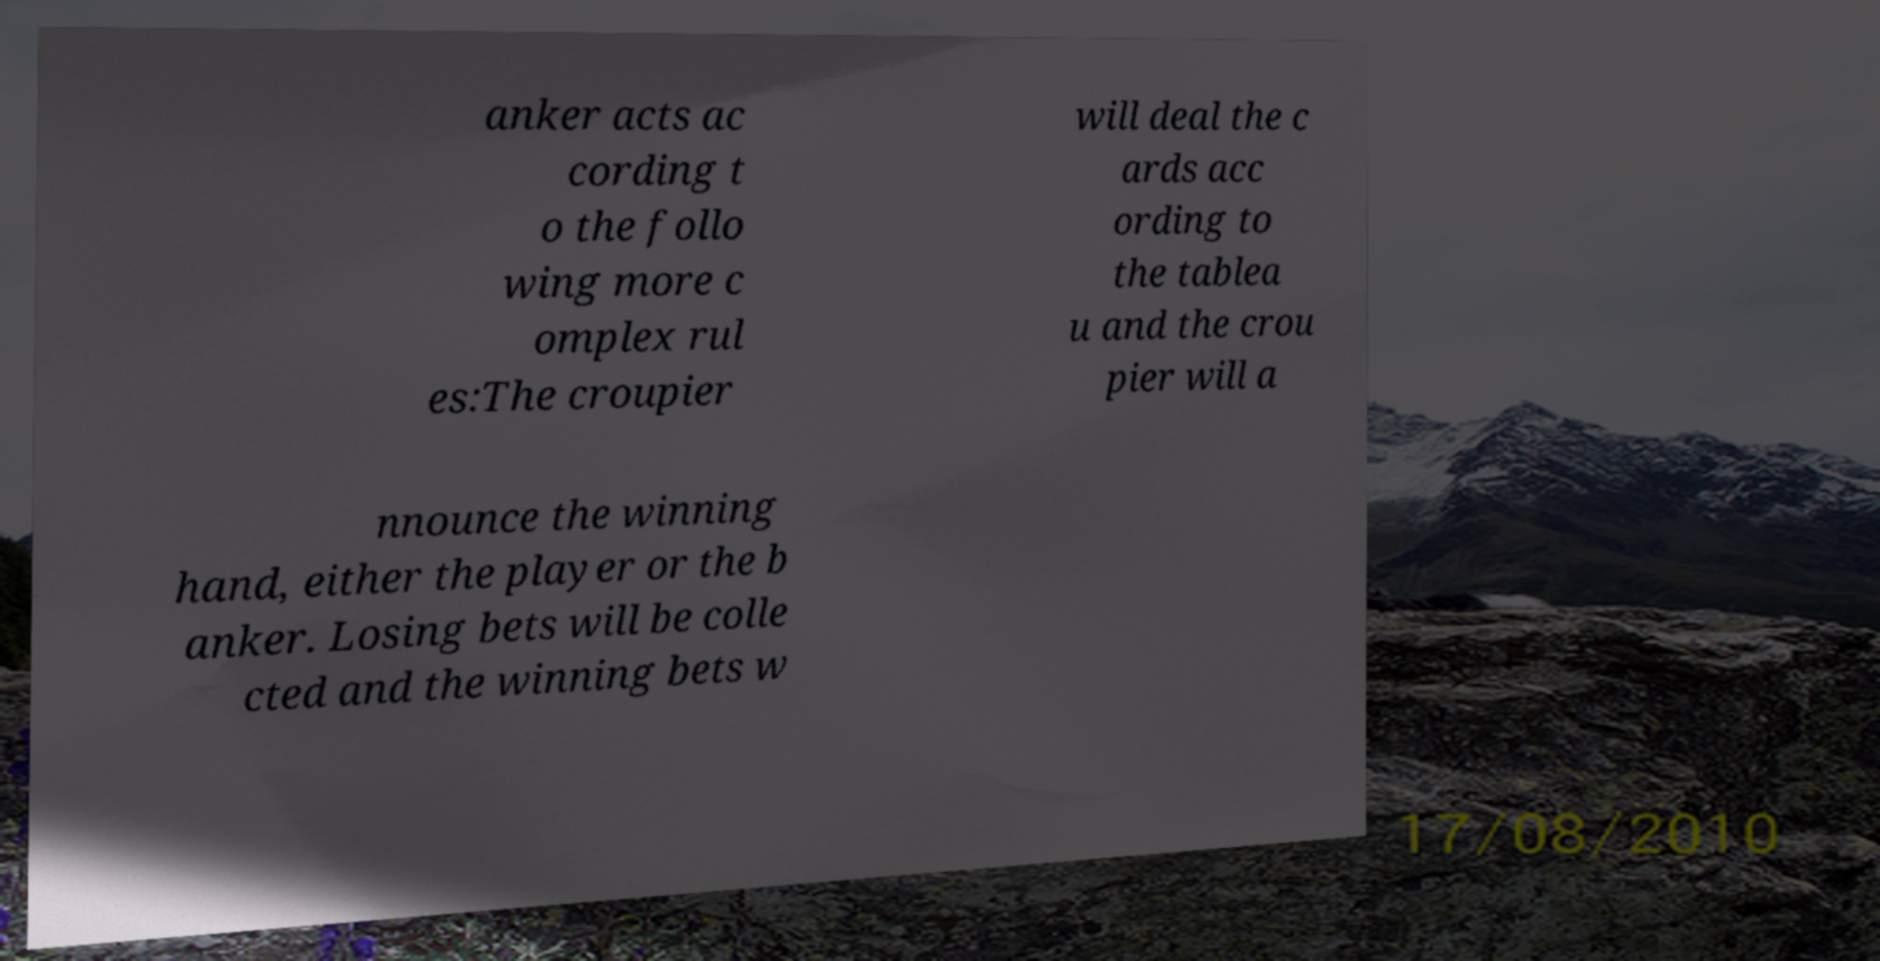For documentation purposes, I need the text within this image transcribed. Could you provide that? anker acts ac cording t o the follo wing more c omplex rul es:The croupier will deal the c ards acc ording to the tablea u and the crou pier will a nnounce the winning hand, either the player or the b anker. Losing bets will be colle cted and the winning bets w 